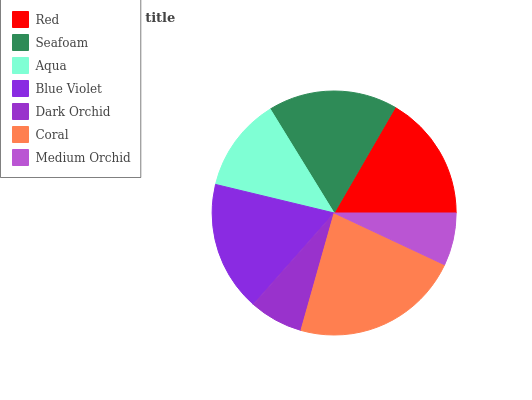Is Medium Orchid the minimum?
Answer yes or no. Yes. Is Coral the maximum?
Answer yes or no. Yes. Is Seafoam the minimum?
Answer yes or no. No. Is Seafoam the maximum?
Answer yes or no. No. Is Seafoam greater than Red?
Answer yes or no. Yes. Is Red less than Seafoam?
Answer yes or no. Yes. Is Red greater than Seafoam?
Answer yes or no. No. Is Seafoam less than Red?
Answer yes or no. No. Is Red the high median?
Answer yes or no. Yes. Is Red the low median?
Answer yes or no. Yes. Is Seafoam the high median?
Answer yes or no. No. Is Dark Orchid the low median?
Answer yes or no. No. 